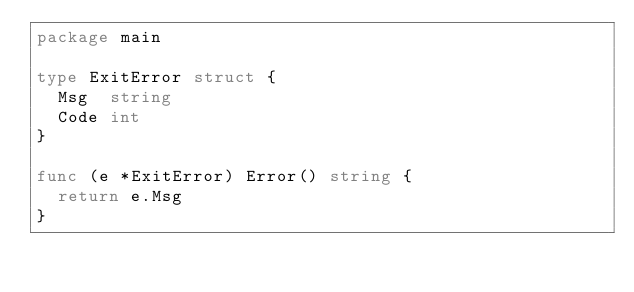Convert code to text. <code><loc_0><loc_0><loc_500><loc_500><_Go_>package main

type ExitError struct {
	Msg  string
	Code int
}

func (e *ExitError) Error() string {
	return e.Msg
}
</code> 